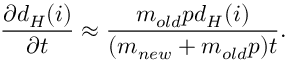Convert formula to latex. <formula><loc_0><loc_0><loc_500><loc_500>\frac { \partial d _ { H } ( i ) } { \partial t } \approx \frac { m _ { o l d } p d _ { H } ( i ) } { ( m _ { n e w } + m _ { o l d } p ) t } .</formula> 